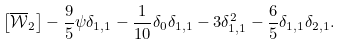Convert formula to latex. <formula><loc_0><loc_0><loc_500><loc_500>\left [ \overline { \mathcal { W } } _ { 2 } \right ] - \frac { 9 } { 5 } \psi \delta _ { 1 , 1 } - \frac { 1 } { 1 0 } \delta _ { 0 } \delta _ { 1 , 1 } - 3 \delta _ { 1 , 1 } ^ { 2 } - \frac { 6 } { 5 } \delta _ { 1 , 1 } \delta _ { 2 , 1 } .</formula> 